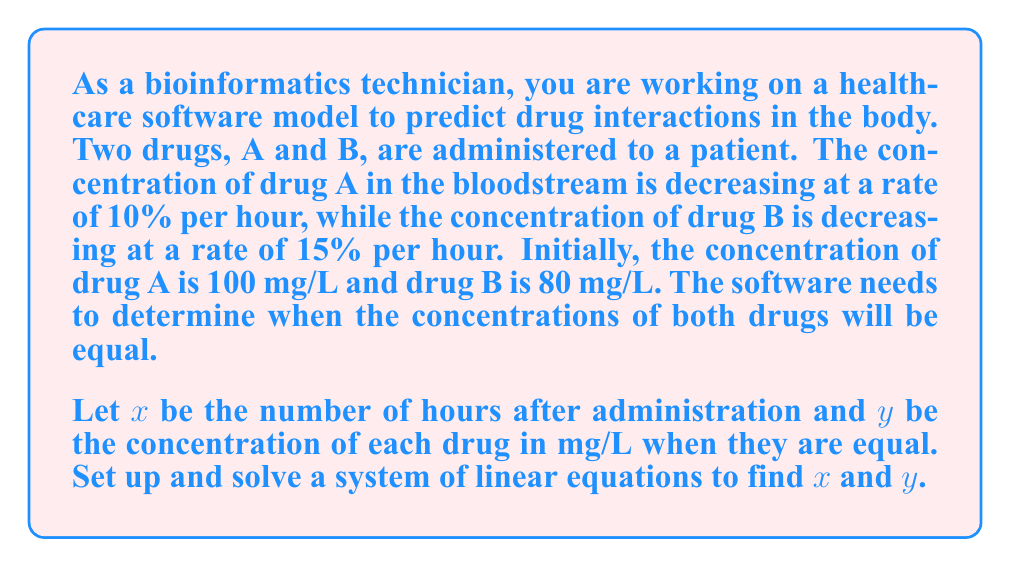What is the answer to this math problem? To solve this problem, we need to set up two equations representing the concentration of each drug over time and then solve for when they are equal.

1. Set up the equations:
   For drug A: $y = 100(0.9)^x$
   For drug B: $y = 80(0.85)^x$

2. Set the equations equal to each other:
   $100(0.9)^x = 80(0.85)^x$

3. Divide both sides by 80:
   $\frac{5}{4}(0.9)^x = (0.85)^x$

4. Take the natural logarithm of both sides:
   $\ln(\frac{5}{4}) + x\ln(0.9) = x\ln(0.85)$

5. Solve for $x$:
   $\ln(\frac{5}{4}) = x\ln(0.85) - x\ln(0.9)$
   $\ln(\frac{5}{4}) = x(\ln(0.85) - \ln(0.9))$
   $x = \frac{\ln(\frac{5}{4})}{\ln(0.85) - \ln(0.9)}$

6. Calculate $x$ using a calculator:
   $x \approx 3.858$ hours

7. To find $y$, substitute $x$ back into either of the original equations:
   $y = 100(0.9)^{3.858} \approx 69.652$ mg/L

Therefore, the concentrations of both drugs will be equal after approximately 3.858 hours, at a concentration of about 69.652 mg/L.
Answer: $x \approx 3.858$ hours, $y \approx 69.652$ mg/L 